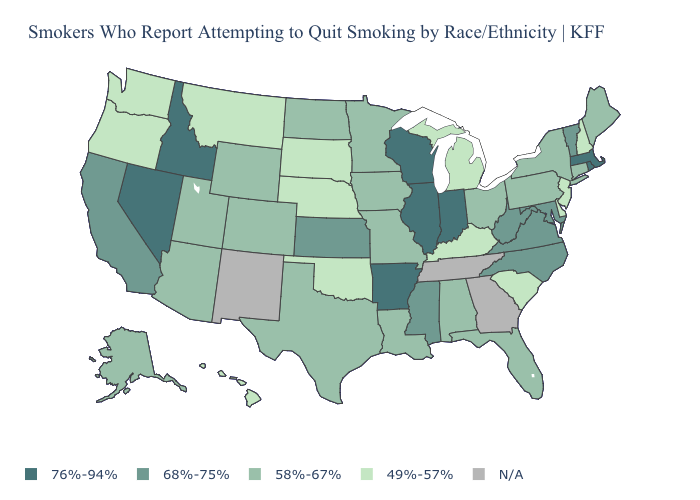What is the value of Arkansas?
Be succinct. 76%-94%. Name the states that have a value in the range N/A?
Answer briefly. Georgia, New Mexico, Tennessee. Does New Jersey have the lowest value in the USA?
Quick response, please. Yes. What is the value of Nevada?
Short answer required. 76%-94%. Name the states that have a value in the range 68%-75%?
Be succinct. California, Kansas, Maryland, Mississippi, North Carolina, Vermont, Virginia, West Virginia. What is the highest value in states that border New Mexico?
Keep it brief. 58%-67%. Which states hav the highest value in the West?
Write a very short answer. Idaho, Nevada. What is the value of South Carolina?
Write a very short answer. 49%-57%. Does Wyoming have the highest value in the USA?
Answer briefly. No. Name the states that have a value in the range 76%-94%?
Quick response, please. Arkansas, Idaho, Illinois, Indiana, Massachusetts, Nevada, Rhode Island, Wisconsin. What is the value of Maryland?
Quick response, please. 68%-75%. Among the states that border Ohio , which have the highest value?
Write a very short answer. Indiana. What is the lowest value in the MidWest?
Concise answer only. 49%-57%. Does Florida have the lowest value in the South?
Keep it brief. No. 